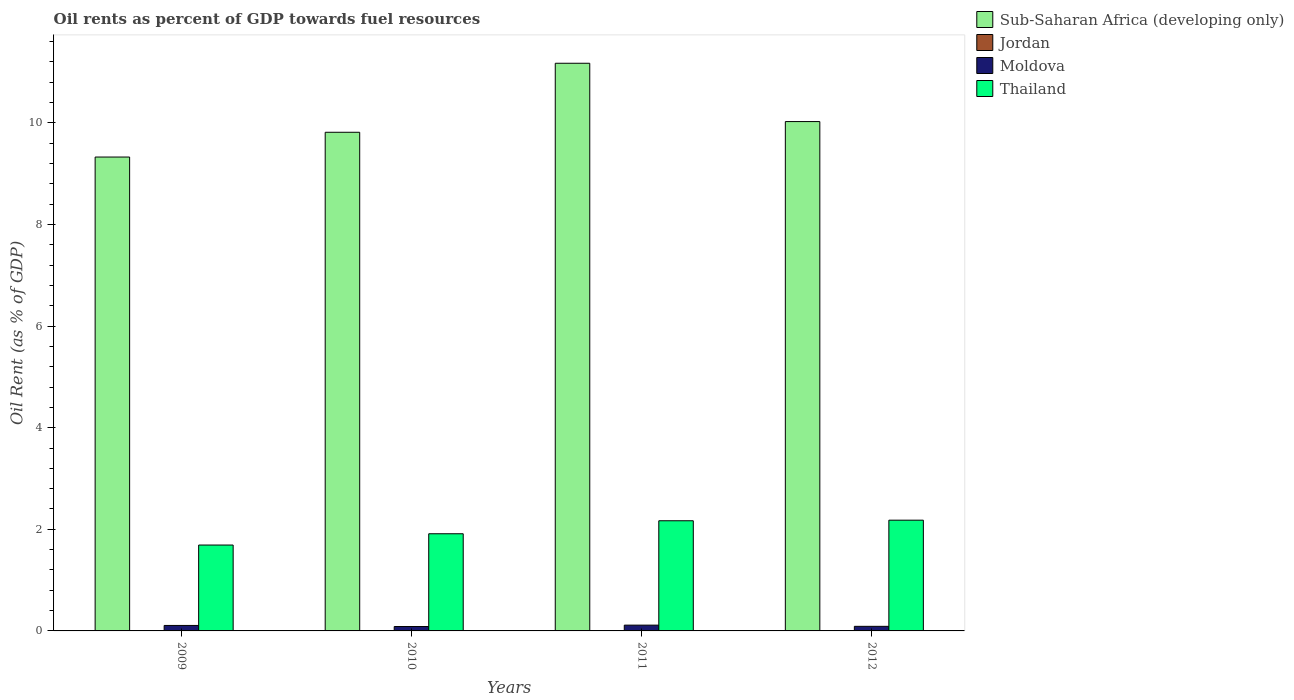How many different coloured bars are there?
Ensure brevity in your answer.  4. How many groups of bars are there?
Give a very brief answer. 4. Are the number of bars per tick equal to the number of legend labels?
Your answer should be very brief. Yes. What is the label of the 1st group of bars from the left?
Make the answer very short. 2009. What is the oil rent in Jordan in 2009?
Offer a terse response. 0. Across all years, what is the maximum oil rent in Sub-Saharan Africa (developing only)?
Your answer should be very brief. 11.17. Across all years, what is the minimum oil rent in Sub-Saharan Africa (developing only)?
Provide a succinct answer. 9.33. In which year was the oil rent in Thailand minimum?
Your answer should be very brief. 2009. What is the total oil rent in Sub-Saharan Africa (developing only) in the graph?
Keep it short and to the point. 40.34. What is the difference between the oil rent in Jordan in 2009 and that in 2010?
Your answer should be compact. -0. What is the difference between the oil rent in Jordan in 2011 and the oil rent in Thailand in 2012?
Your response must be concise. -2.18. What is the average oil rent in Jordan per year?
Your answer should be compact. 0. In the year 2010, what is the difference between the oil rent in Sub-Saharan Africa (developing only) and oil rent in Jordan?
Give a very brief answer. 9.81. In how many years, is the oil rent in Jordan greater than 10.8 %?
Offer a very short reply. 0. What is the ratio of the oil rent in Moldova in 2009 to that in 2012?
Provide a short and direct response. 1.19. Is the oil rent in Jordan in 2010 less than that in 2011?
Your answer should be very brief. Yes. What is the difference between the highest and the second highest oil rent in Sub-Saharan Africa (developing only)?
Ensure brevity in your answer.  1.15. What is the difference between the highest and the lowest oil rent in Sub-Saharan Africa (developing only)?
Provide a succinct answer. 1.85. Is the sum of the oil rent in Moldova in 2011 and 2012 greater than the maximum oil rent in Sub-Saharan Africa (developing only) across all years?
Offer a terse response. No. Is it the case that in every year, the sum of the oil rent in Sub-Saharan Africa (developing only) and oil rent in Jordan is greater than the sum of oil rent in Moldova and oil rent in Thailand?
Keep it short and to the point. Yes. What does the 1st bar from the left in 2011 represents?
Provide a succinct answer. Sub-Saharan Africa (developing only). What does the 1st bar from the right in 2011 represents?
Provide a succinct answer. Thailand. Is it the case that in every year, the sum of the oil rent in Sub-Saharan Africa (developing only) and oil rent in Moldova is greater than the oil rent in Jordan?
Your answer should be compact. Yes. How many bars are there?
Provide a succinct answer. 16. How many years are there in the graph?
Make the answer very short. 4. Are the values on the major ticks of Y-axis written in scientific E-notation?
Give a very brief answer. No. Does the graph contain grids?
Offer a terse response. No. Where does the legend appear in the graph?
Offer a terse response. Top right. How many legend labels are there?
Provide a short and direct response. 4. What is the title of the graph?
Provide a short and direct response. Oil rents as percent of GDP towards fuel resources. What is the label or title of the Y-axis?
Offer a very short reply. Oil Rent (as % of GDP). What is the Oil Rent (as % of GDP) in Sub-Saharan Africa (developing only) in 2009?
Make the answer very short. 9.33. What is the Oil Rent (as % of GDP) of Jordan in 2009?
Ensure brevity in your answer.  0. What is the Oil Rent (as % of GDP) in Moldova in 2009?
Your answer should be very brief. 0.11. What is the Oil Rent (as % of GDP) in Thailand in 2009?
Your answer should be very brief. 1.69. What is the Oil Rent (as % of GDP) in Sub-Saharan Africa (developing only) in 2010?
Offer a very short reply. 9.82. What is the Oil Rent (as % of GDP) in Jordan in 2010?
Provide a succinct answer. 0. What is the Oil Rent (as % of GDP) in Moldova in 2010?
Ensure brevity in your answer.  0.09. What is the Oil Rent (as % of GDP) in Thailand in 2010?
Provide a short and direct response. 1.91. What is the Oil Rent (as % of GDP) of Sub-Saharan Africa (developing only) in 2011?
Your answer should be very brief. 11.17. What is the Oil Rent (as % of GDP) of Jordan in 2011?
Give a very brief answer. 0. What is the Oil Rent (as % of GDP) in Moldova in 2011?
Ensure brevity in your answer.  0.11. What is the Oil Rent (as % of GDP) of Thailand in 2011?
Your answer should be compact. 2.17. What is the Oil Rent (as % of GDP) in Sub-Saharan Africa (developing only) in 2012?
Make the answer very short. 10.03. What is the Oil Rent (as % of GDP) in Jordan in 2012?
Your response must be concise. 0. What is the Oil Rent (as % of GDP) of Moldova in 2012?
Give a very brief answer. 0.09. What is the Oil Rent (as % of GDP) of Thailand in 2012?
Keep it short and to the point. 2.18. Across all years, what is the maximum Oil Rent (as % of GDP) in Sub-Saharan Africa (developing only)?
Offer a very short reply. 11.17. Across all years, what is the maximum Oil Rent (as % of GDP) in Jordan?
Offer a terse response. 0. Across all years, what is the maximum Oil Rent (as % of GDP) of Moldova?
Make the answer very short. 0.11. Across all years, what is the maximum Oil Rent (as % of GDP) of Thailand?
Provide a succinct answer. 2.18. Across all years, what is the minimum Oil Rent (as % of GDP) of Sub-Saharan Africa (developing only)?
Offer a very short reply. 9.33. Across all years, what is the minimum Oil Rent (as % of GDP) of Jordan?
Provide a short and direct response. 0. Across all years, what is the minimum Oil Rent (as % of GDP) of Moldova?
Give a very brief answer. 0.09. Across all years, what is the minimum Oil Rent (as % of GDP) of Thailand?
Offer a terse response. 1.69. What is the total Oil Rent (as % of GDP) in Sub-Saharan Africa (developing only) in the graph?
Your answer should be very brief. 40.34. What is the total Oil Rent (as % of GDP) in Jordan in the graph?
Your response must be concise. 0.01. What is the total Oil Rent (as % of GDP) of Moldova in the graph?
Your answer should be very brief. 0.4. What is the total Oil Rent (as % of GDP) of Thailand in the graph?
Make the answer very short. 7.95. What is the difference between the Oil Rent (as % of GDP) of Sub-Saharan Africa (developing only) in 2009 and that in 2010?
Your answer should be compact. -0.49. What is the difference between the Oil Rent (as % of GDP) of Jordan in 2009 and that in 2010?
Give a very brief answer. -0. What is the difference between the Oil Rent (as % of GDP) in Moldova in 2009 and that in 2010?
Provide a short and direct response. 0.02. What is the difference between the Oil Rent (as % of GDP) of Thailand in 2009 and that in 2010?
Your response must be concise. -0.22. What is the difference between the Oil Rent (as % of GDP) of Sub-Saharan Africa (developing only) in 2009 and that in 2011?
Offer a terse response. -1.85. What is the difference between the Oil Rent (as % of GDP) of Jordan in 2009 and that in 2011?
Provide a short and direct response. -0. What is the difference between the Oil Rent (as % of GDP) in Moldova in 2009 and that in 2011?
Your answer should be compact. -0.01. What is the difference between the Oil Rent (as % of GDP) of Thailand in 2009 and that in 2011?
Provide a succinct answer. -0.48. What is the difference between the Oil Rent (as % of GDP) of Sub-Saharan Africa (developing only) in 2009 and that in 2012?
Offer a very short reply. -0.7. What is the difference between the Oil Rent (as % of GDP) of Jordan in 2009 and that in 2012?
Offer a terse response. -0. What is the difference between the Oil Rent (as % of GDP) in Moldova in 2009 and that in 2012?
Keep it short and to the point. 0.02. What is the difference between the Oil Rent (as % of GDP) in Thailand in 2009 and that in 2012?
Your response must be concise. -0.49. What is the difference between the Oil Rent (as % of GDP) in Sub-Saharan Africa (developing only) in 2010 and that in 2011?
Keep it short and to the point. -1.36. What is the difference between the Oil Rent (as % of GDP) in Jordan in 2010 and that in 2011?
Provide a short and direct response. -0. What is the difference between the Oil Rent (as % of GDP) of Moldova in 2010 and that in 2011?
Ensure brevity in your answer.  -0.03. What is the difference between the Oil Rent (as % of GDP) of Thailand in 2010 and that in 2011?
Ensure brevity in your answer.  -0.26. What is the difference between the Oil Rent (as % of GDP) of Sub-Saharan Africa (developing only) in 2010 and that in 2012?
Give a very brief answer. -0.21. What is the difference between the Oil Rent (as % of GDP) in Jordan in 2010 and that in 2012?
Provide a succinct answer. -0. What is the difference between the Oil Rent (as % of GDP) of Moldova in 2010 and that in 2012?
Your answer should be compact. -0. What is the difference between the Oil Rent (as % of GDP) in Thailand in 2010 and that in 2012?
Give a very brief answer. -0.27. What is the difference between the Oil Rent (as % of GDP) in Sub-Saharan Africa (developing only) in 2011 and that in 2012?
Keep it short and to the point. 1.15. What is the difference between the Oil Rent (as % of GDP) in Jordan in 2011 and that in 2012?
Offer a terse response. -0. What is the difference between the Oil Rent (as % of GDP) of Moldova in 2011 and that in 2012?
Ensure brevity in your answer.  0.02. What is the difference between the Oil Rent (as % of GDP) in Thailand in 2011 and that in 2012?
Your answer should be very brief. -0.01. What is the difference between the Oil Rent (as % of GDP) of Sub-Saharan Africa (developing only) in 2009 and the Oil Rent (as % of GDP) of Jordan in 2010?
Your answer should be very brief. 9.33. What is the difference between the Oil Rent (as % of GDP) of Sub-Saharan Africa (developing only) in 2009 and the Oil Rent (as % of GDP) of Moldova in 2010?
Offer a very short reply. 9.24. What is the difference between the Oil Rent (as % of GDP) in Sub-Saharan Africa (developing only) in 2009 and the Oil Rent (as % of GDP) in Thailand in 2010?
Your answer should be compact. 7.42. What is the difference between the Oil Rent (as % of GDP) in Jordan in 2009 and the Oil Rent (as % of GDP) in Moldova in 2010?
Your answer should be compact. -0.09. What is the difference between the Oil Rent (as % of GDP) in Jordan in 2009 and the Oil Rent (as % of GDP) in Thailand in 2010?
Ensure brevity in your answer.  -1.91. What is the difference between the Oil Rent (as % of GDP) in Moldova in 2009 and the Oil Rent (as % of GDP) in Thailand in 2010?
Keep it short and to the point. -1.8. What is the difference between the Oil Rent (as % of GDP) of Sub-Saharan Africa (developing only) in 2009 and the Oil Rent (as % of GDP) of Jordan in 2011?
Your answer should be very brief. 9.33. What is the difference between the Oil Rent (as % of GDP) of Sub-Saharan Africa (developing only) in 2009 and the Oil Rent (as % of GDP) of Moldova in 2011?
Provide a succinct answer. 9.21. What is the difference between the Oil Rent (as % of GDP) in Sub-Saharan Africa (developing only) in 2009 and the Oil Rent (as % of GDP) in Thailand in 2011?
Your response must be concise. 7.16. What is the difference between the Oil Rent (as % of GDP) in Jordan in 2009 and the Oil Rent (as % of GDP) in Moldova in 2011?
Offer a very short reply. -0.11. What is the difference between the Oil Rent (as % of GDP) in Jordan in 2009 and the Oil Rent (as % of GDP) in Thailand in 2011?
Your answer should be compact. -2.17. What is the difference between the Oil Rent (as % of GDP) in Moldova in 2009 and the Oil Rent (as % of GDP) in Thailand in 2011?
Offer a terse response. -2.06. What is the difference between the Oil Rent (as % of GDP) in Sub-Saharan Africa (developing only) in 2009 and the Oil Rent (as % of GDP) in Jordan in 2012?
Your response must be concise. 9.33. What is the difference between the Oil Rent (as % of GDP) in Sub-Saharan Africa (developing only) in 2009 and the Oil Rent (as % of GDP) in Moldova in 2012?
Offer a very short reply. 9.24. What is the difference between the Oil Rent (as % of GDP) of Sub-Saharan Africa (developing only) in 2009 and the Oil Rent (as % of GDP) of Thailand in 2012?
Provide a short and direct response. 7.15. What is the difference between the Oil Rent (as % of GDP) in Jordan in 2009 and the Oil Rent (as % of GDP) in Moldova in 2012?
Offer a terse response. -0.09. What is the difference between the Oil Rent (as % of GDP) in Jordan in 2009 and the Oil Rent (as % of GDP) in Thailand in 2012?
Offer a very short reply. -2.18. What is the difference between the Oil Rent (as % of GDP) in Moldova in 2009 and the Oil Rent (as % of GDP) in Thailand in 2012?
Provide a succinct answer. -2.07. What is the difference between the Oil Rent (as % of GDP) of Sub-Saharan Africa (developing only) in 2010 and the Oil Rent (as % of GDP) of Jordan in 2011?
Ensure brevity in your answer.  9.81. What is the difference between the Oil Rent (as % of GDP) of Sub-Saharan Africa (developing only) in 2010 and the Oil Rent (as % of GDP) of Moldova in 2011?
Your answer should be very brief. 9.7. What is the difference between the Oil Rent (as % of GDP) in Sub-Saharan Africa (developing only) in 2010 and the Oil Rent (as % of GDP) in Thailand in 2011?
Keep it short and to the point. 7.65. What is the difference between the Oil Rent (as % of GDP) in Jordan in 2010 and the Oil Rent (as % of GDP) in Moldova in 2011?
Offer a terse response. -0.11. What is the difference between the Oil Rent (as % of GDP) in Jordan in 2010 and the Oil Rent (as % of GDP) in Thailand in 2011?
Your answer should be very brief. -2.17. What is the difference between the Oil Rent (as % of GDP) in Moldova in 2010 and the Oil Rent (as % of GDP) in Thailand in 2011?
Provide a succinct answer. -2.08. What is the difference between the Oil Rent (as % of GDP) of Sub-Saharan Africa (developing only) in 2010 and the Oil Rent (as % of GDP) of Jordan in 2012?
Provide a succinct answer. 9.81. What is the difference between the Oil Rent (as % of GDP) of Sub-Saharan Africa (developing only) in 2010 and the Oil Rent (as % of GDP) of Moldova in 2012?
Make the answer very short. 9.73. What is the difference between the Oil Rent (as % of GDP) of Sub-Saharan Africa (developing only) in 2010 and the Oil Rent (as % of GDP) of Thailand in 2012?
Give a very brief answer. 7.64. What is the difference between the Oil Rent (as % of GDP) in Jordan in 2010 and the Oil Rent (as % of GDP) in Moldova in 2012?
Give a very brief answer. -0.09. What is the difference between the Oil Rent (as % of GDP) of Jordan in 2010 and the Oil Rent (as % of GDP) of Thailand in 2012?
Offer a terse response. -2.18. What is the difference between the Oil Rent (as % of GDP) of Moldova in 2010 and the Oil Rent (as % of GDP) of Thailand in 2012?
Your response must be concise. -2.09. What is the difference between the Oil Rent (as % of GDP) of Sub-Saharan Africa (developing only) in 2011 and the Oil Rent (as % of GDP) of Jordan in 2012?
Your answer should be compact. 11.17. What is the difference between the Oil Rent (as % of GDP) of Sub-Saharan Africa (developing only) in 2011 and the Oil Rent (as % of GDP) of Moldova in 2012?
Make the answer very short. 11.08. What is the difference between the Oil Rent (as % of GDP) of Sub-Saharan Africa (developing only) in 2011 and the Oil Rent (as % of GDP) of Thailand in 2012?
Offer a very short reply. 8.99. What is the difference between the Oil Rent (as % of GDP) of Jordan in 2011 and the Oil Rent (as % of GDP) of Moldova in 2012?
Provide a short and direct response. -0.09. What is the difference between the Oil Rent (as % of GDP) in Jordan in 2011 and the Oil Rent (as % of GDP) in Thailand in 2012?
Ensure brevity in your answer.  -2.18. What is the difference between the Oil Rent (as % of GDP) of Moldova in 2011 and the Oil Rent (as % of GDP) of Thailand in 2012?
Your answer should be compact. -2.07. What is the average Oil Rent (as % of GDP) of Sub-Saharan Africa (developing only) per year?
Keep it short and to the point. 10.09. What is the average Oil Rent (as % of GDP) of Jordan per year?
Give a very brief answer. 0. What is the average Oil Rent (as % of GDP) in Moldova per year?
Your answer should be very brief. 0.1. What is the average Oil Rent (as % of GDP) of Thailand per year?
Offer a terse response. 1.99. In the year 2009, what is the difference between the Oil Rent (as % of GDP) in Sub-Saharan Africa (developing only) and Oil Rent (as % of GDP) in Jordan?
Give a very brief answer. 9.33. In the year 2009, what is the difference between the Oil Rent (as % of GDP) in Sub-Saharan Africa (developing only) and Oil Rent (as % of GDP) in Moldova?
Your response must be concise. 9.22. In the year 2009, what is the difference between the Oil Rent (as % of GDP) of Sub-Saharan Africa (developing only) and Oil Rent (as % of GDP) of Thailand?
Provide a succinct answer. 7.64. In the year 2009, what is the difference between the Oil Rent (as % of GDP) in Jordan and Oil Rent (as % of GDP) in Moldova?
Offer a terse response. -0.11. In the year 2009, what is the difference between the Oil Rent (as % of GDP) of Jordan and Oil Rent (as % of GDP) of Thailand?
Make the answer very short. -1.69. In the year 2009, what is the difference between the Oil Rent (as % of GDP) in Moldova and Oil Rent (as % of GDP) in Thailand?
Offer a very short reply. -1.58. In the year 2010, what is the difference between the Oil Rent (as % of GDP) in Sub-Saharan Africa (developing only) and Oil Rent (as % of GDP) in Jordan?
Give a very brief answer. 9.81. In the year 2010, what is the difference between the Oil Rent (as % of GDP) of Sub-Saharan Africa (developing only) and Oil Rent (as % of GDP) of Moldova?
Make the answer very short. 9.73. In the year 2010, what is the difference between the Oil Rent (as % of GDP) of Sub-Saharan Africa (developing only) and Oil Rent (as % of GDP) of Thailand?
Keep it short and to the point. 7.9. In the year 2010, what is the difference between the Oil Rent (as % of GDP) in Jordan and Oil Rent (as % of GDP) in Moldova?
Provide a succinct answer. -0.08. In the year 2010, what is the difference between the Oil Rent (as % of GDP) of Jordan and Oil Rent (as % of GDP) of Thailand?
Provide a short and direct response. -1.91. In the year 2010, what is the difference between the Oil Rent (as % of GDP) in Moldova and Oil Rent (as % of GDP) in Thailand?
Your answer should be compact. -1.83. In the year 2011, what is the difference between the Oil Rent (as % of GDP) of Sub-Saharan Africa (developing only) and Oil Rent (as % of GDP) of Jordan?
Provide a succinct answer. 11.17. In the year 2011, what is the difference between the Oil Rent (as % of GDP) in Sub-Saharan Africa (developing only) and Oil Rent (as % of GDP) in Moldova?
Your response must be concise. 11.06. In the year 2011, what is the difference between the Oil Rent (as % of GDP) of Sub-Saharan Africa (developing only) and Oil Rent (as % of GDP) of Thailand?
Make the answer very short. 9.01. In the year 2011, what is the difference between the Oil Rent (as % of GDP) of Jordan and Oil Rent (as % of GDP) of Moldova?
Your answer should be very brief. -0.11. In the year 2011, what is the difference between the Oil Rent (as % of GDP) in Jordan and Oil Rent (as % of GDP) in Thailand?
Ensure brevity in your answer.  -2.17. In the year 2011, what is the difference between the Oil Rent (as % of GDP) of Moldova and Oil Rent (as % of GDP) of Thailand?
Offer a terse response. -2.05. In the year 2012, what is the difference between the Oil Rent (as % of GDP) of Sub-Saharan Africa (developing only) and Oil Rent (as % of GDP) of Jordan?
Ensure brevity in your answer.  10.02. In the year 2012, what is the difference between the Oil Rent (as % of GDP) of Sub-Saharan Africa (developing only) and Oil Rent (as % of GDP) of Moldova?
Give a very brief answer. 9.94. In the year 2012, what is the difference between the Oil Rent (as % of GDP) of Sub-Saharan Africa (developing only) and Oil Rent (as % of GDP) of Thailand?
Ensure brevity in your answer.  7.85. In the year 2012, what is the difference between the Oil Rent (as % of GDP) in Jordan and Oil Rent (as % of GDP) in Moldova?
Your response must be concise. -0.09. In the year 2012, what is the difference between the Oil Rent (as % of GDP) in Jordan and Oil Rent (as % of GDP) in Thailand?
Offer a terse response. -2.18. In the year 2012, what is the difference between the Oil Rent (as % of GDP) in Moldova and Oil Rent (as % of GDP) in Thailand?
Keep it short and to the point. -2.09. What is the ratio of the Oil Rent (as % of GDP) in Sub-Saharan Africa (developing only) in 2009 to that in 2010?
Provide a short and direct response. 0.95. What is the ratio of the Oil Rent (as % of GDP) in Jordan in 2009 to that in 2010?
Ensure brevity in your answer.  0.84. What is the ratio of the Oil Rent (as % of GDP) of Moldova in 2009 to that in 2010?
Keep it short and to the point. 1.24. What is the ratio of the Oil Rent (as % of GDP) in Thailand in 2009 to that in 2010?
Offer a very short reply. 0.88. What is the ratio of the Oil Rent (as % of GDP) in Sub-Saharan Africa (developing only) in 2009 to that in 2011?
Make the answer very short. 0.83. What is the ratio of the Oil Rent (as % of GDP) of Jordan in 2009 to that in 2011?
Give a very brief answer. 0.77. What is the ratio of the Oil Rent (as % of GDP) of Moldova in 2009 to that in 2011?
Give a very brief answer. 0.95. What is the ratio of the Oil Rent (as % of GDP) in Thailand in 2009 to that in 2011?
Keep it short and to the point. 0.78. What is the ratio of the Oil Rent (as % of GDP) of Sub-Saharan Africa (developing only) in 2009 to that in 2012?
Keep it short and to the point. 0.93. What is the ratio of the Oil Rent (as % of GDP) in Jordan in 2009 to that in 2012?
Offer a terse response. 0.68. What is the ratio of the Oil Rent (as % of GDP) in Moldova in 2009 to that in 2012?
Your answer should be compact. 1.19. What is the ratio of the Oil Rent (as % of GDP) in Thailand in 2009 to that in 2012?
Your answer should be very brief. 0.78. What is the ratio of the Oil Rent (as % of GDP) of Sub-Saharan Africa (developing only) in 2010 to that in 2011?
Your answer should be very brief. 0.88. What is the ratio of the Oil Rent (as % of GDP) in Jordan in 2010 to that in 2011?
Provide a succinct answer. 0.91. What is the ratio of the Oil Rent (as % of GDP) of Moldova in 2010 to that in 2011?
Keep it short and to the point. 0.76. What is the ratio of the Oil Rent (as % of GDP) in Thailand in 2010 to that in 2011?
Offer a very short reply. 0.88. What is the ratio of the Oil Rent (as % of GDP) in Sub-Saharan Africa (developing only) in 2010 to that in 2012?
Offer a terse response. 0.98. What is the ratio of the Oil Rent (as % of GDP) of Jordan in 2010 to that in 2012?
Make the answer very short. 0.81. What is the ratio of the Oil Rent (as % of GDP) of Moldova in 2010 to that in 2012?
Ensure brevity in your answer.  0.96. What is the ratio of the Oil Rent (as % of GDP) in Thailand in 2010 to that in 2012?
Ensure brevity in your answer.  0.88. What is the ratio of the Oil Rent (as % of GDP) in Sub-Saharan Africa (developing only) in 2011 to that in 2012?
Provide a succinct answer. 1.11. What is the ratio of the Oil Rent (as % of GDP) of Jordan in 2011 to that in 2012?
Ensure brevity in your answer.  0.89. What is the ratio of the Oil Rent (as % of GDP) in Moldova in 2011 to that in 2012?
Keep it short and to the point. 1.26. What is the ratio of the Oil Rent (as % of GDP) in Thailand in 2011 to that in 2012?
Give a very brief answer. 0.99. What is the difference between the highest and the second highest Oil Rent (as % of GDP) of Sub-Saharan Africa (developing only)?
Offer a very short reply. 1.15. What is the difference between the highest and the second highest Oil Rent (as % of GDP) of Jordan?
Your answer should be compact. 0. What is the difference between the highest and the second highest Oil Rent (as % of GDP) in Moldova?
Offer a terse response. 0.01. What is the difference between the highest and the second highest Oil Rent (as % of GDP) of Thailand?
Ensure brevity in your answer.  0.01. What is the difference between the highest and the lowest Oil Rent (as % of GDP) of Sub-Saharan Africa (developing only)?
Ensure brevity in your answer.  1.85. What is the difference between the highest and the lowest Oil Rent (as % of GDP) in Jordan?
Make the answer very short. 0. What is the difference between the highest and the lowest Oil Rent (as % of GDP) in Moldova?
Make the answer very short. 0.03. What is the difference between the highest and the lowest Oil Rent (as % of GDP) of Thailand?
Offer a very short reply. 0.49. 